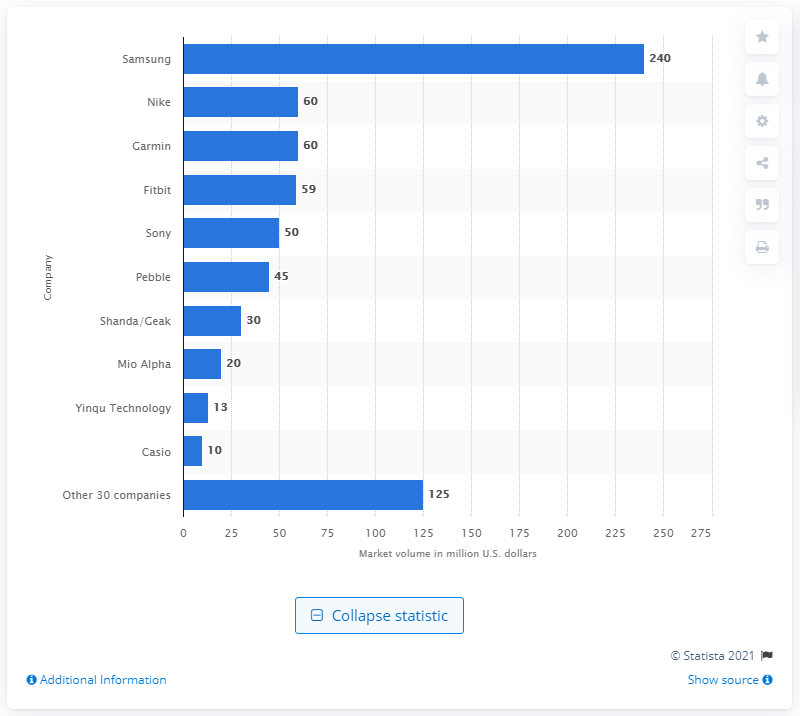Point out several critical features in this image. In 2013, Samsung was the leading company in the smartwatch market. Samsung generated $240 million in revenue in the United States in 2013. 